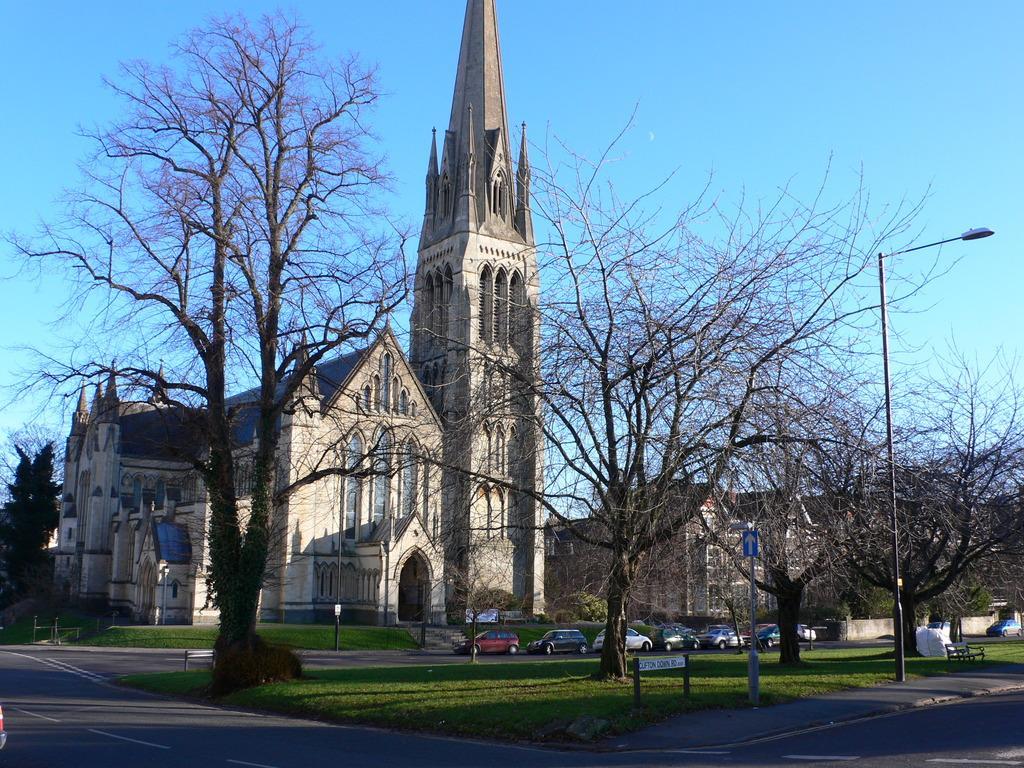Please provide a concise description of this image. In this I can see a building , in front of building there are trees vehicles , road , bench ,pole, light attached to the pole ,at the top I can see the sky. 